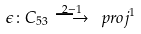<formula> <loc_0><loc_0><loc_500><loc_500>\epsilon \colon C _ { 5 3 } \stackrel { 2 - 1 } { \longrightarrow } \ p r o j ^ { 1 }</formula> 